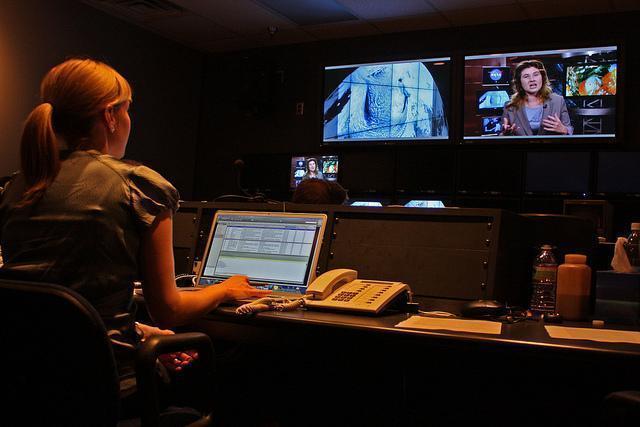What is the woman doing?
Select the correct answer and articulate reasoning with the following format: 'Answer: answer
Rationale: rationale.'
Options: Working, checking emails, taking calls, watching tv. Answer: working.
Rationale: She is monitoring the television show on her computer. 